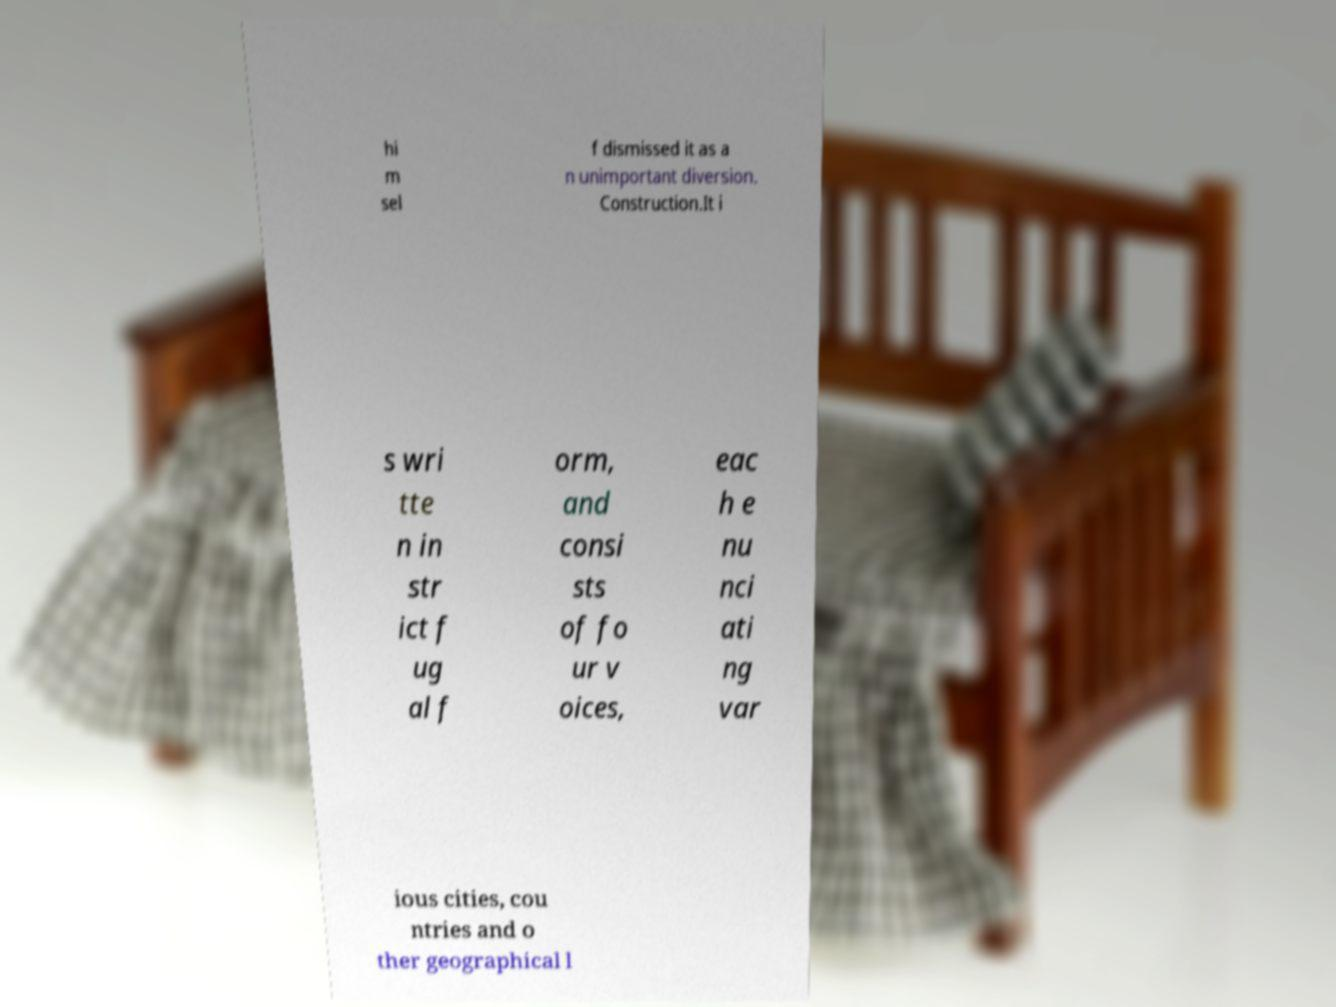Could you assist in decoding the text presented in this image and type it out clearly? hi m sel f dismissed it as a n unimportant diversion. Construction.It i s wri tte n in str ict f ug al f orm, and consi sts of fo ur v oices, eac h e nu nci ati ng var ious cities, cou ntries and o ther geographical l 